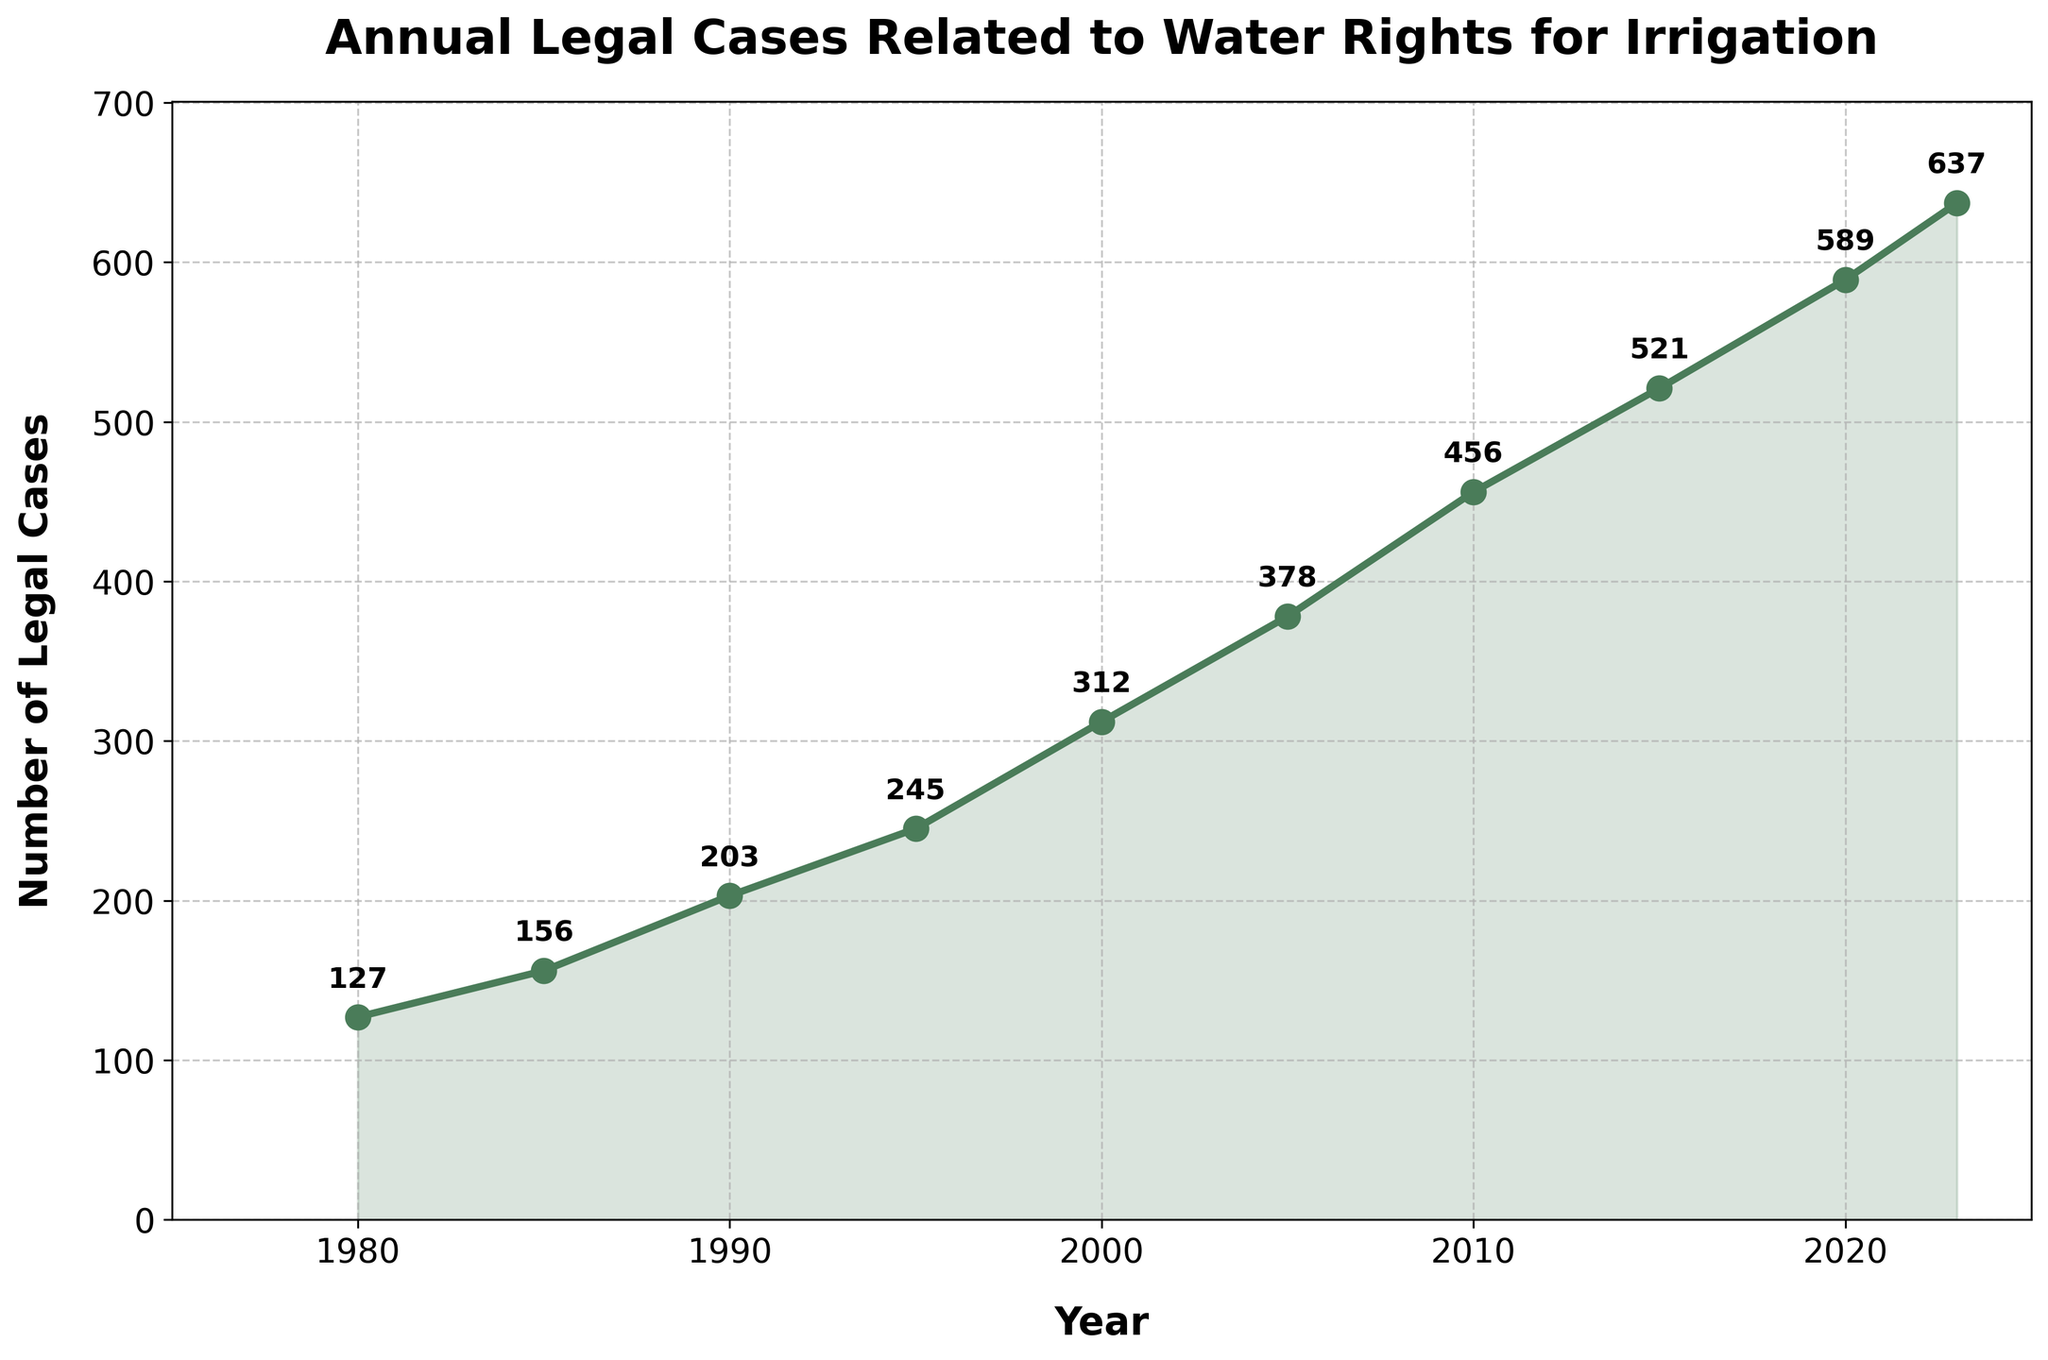How many more legal cases were there in 2023 compared to 1980? In 1980, there were 127 legal cases, and in 2023, there were 637. Subtracting the cases in 1980 from those in 2023 gives 637 - 127 = 510
Answer: 510 Which year saw the highest number of legal cases, and how many were there? Looking at the chart, the year 2023 has the highest number of legal cases, which is 637
Answer: 2023, 637 Between 1990 and 2010, what is the increase in the number of legal cases? In 1990, there were 203 cases, and in 2010, there were 456 cases. The increase is 456 - 203 = 253
Answer: 253 What was the average number of legal cases per year for the years listed in the figure? Adding the legal cases for all years and dividing by the number of years: (127 + 156 + 203 + 245 + 312 + 378 + 456 + 521 + 589 + 637) / 10 = 3524 / 10 = 352.4
Answer: 352.4 By what percentage did the number of legal cases increase from 2000 to 2023? In 2000, there were 312 cases. By 2023, there were 637. The percentage increase is ((637 - 312) / 312) * 100 = 104.17%
Answer: 104.17% Was there a greater increase in legal cases between 1980-1990 or between 2000-2010? From 1980 to 1990, cases increased from 127 to 203, which is 203 - 127 = 76. From 2000 to 2010, cases increased from 312 to 456, which is 456 - 312 = 144. Therefore, the increase was greater between 2000 and 2010.
Answer: 2000-2010 During which decade did the number of legal cases grow the fastest? The visual slope of the curve is steepest between 2000 and 2010, indicating the fastest growth. The number of legal cases increased from 312 to 456, which is a 144 case increase.
Answer: 2000-2010 What is the median number of legal cases over the years listed? The values of legal cases in ascending order: 127, 156, 203, 245, 312, 378, 456, 521, 589, 637. The median is the average of the 5th and 6th values: (312 + 378) / 2 = 690 / 2 = 345
Answer: 345 How many times does the figure use markers to indicate specific data points? Counting the data points marked by circles along the line, there are 10 markers, one for each specified year.
Answer: 10 